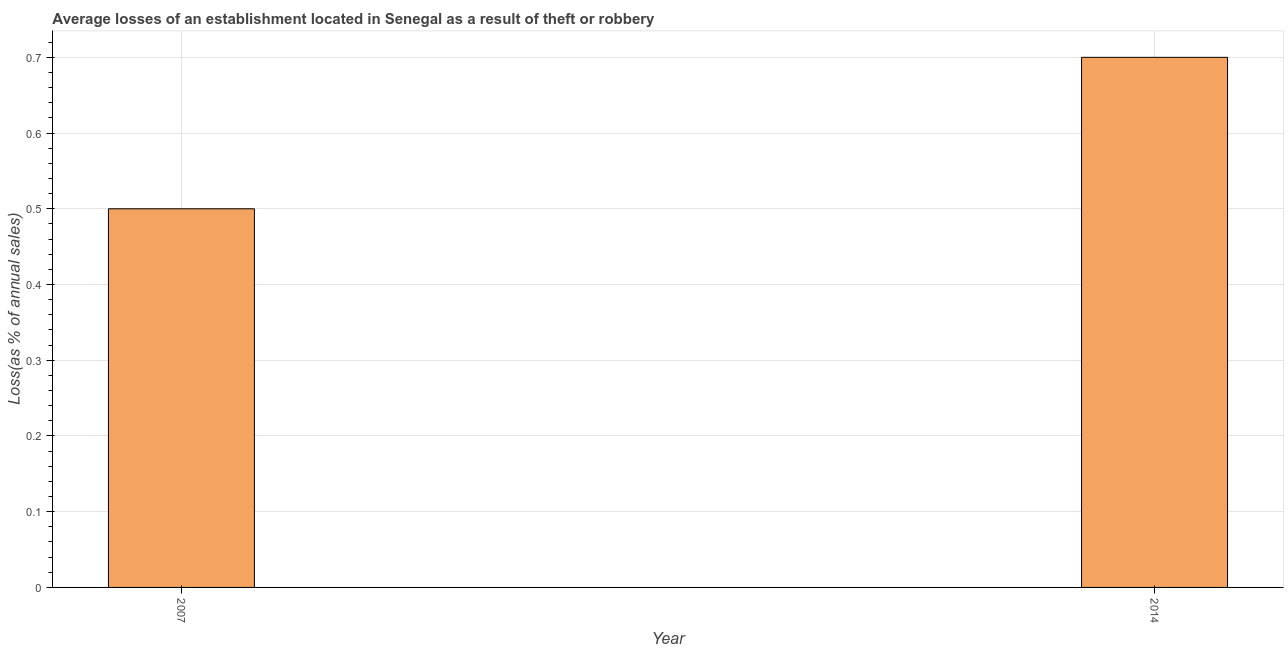Does the graph contain any zero values?
Your answer should be very brief. No. Does the graph contain grids?
Offer a terse response. Yes. What is the title of the graph?
Offer a very short reply. Average losses of an establishment located in Senegal as a result of theft or robbery. What is the label or title of the Y-axis?
Provide a short and direct response. Loss(as % of annual sales). Across all years, what is the maximum losses due to theft?
Make the answer very short. 0.7. What is the median losses due to theft?
Provide a succinct answer. 0.6. What is the ratio of the losses due to theft in 2007 to that in 2014?
Offer a terse response. 0.71. How many bars are there?
Ensure brevity in your answer.  2. Are all the bars in the graph horizontal?
Ensure brevity in your answer.  No. What is the difference between two consecutive major ticks on the Y-axis?
Your response must be concise. 0.1. Are the values on the major ticks of Y-axis written in scientific E-notation?
Ensure brevity in your answer.  No. What is the Loss(as % of annual sales) in 2007?
Offer a very short reply. 0.5. What is the Loss(as % of annual sales) in 2014?
Keep it short and to the point. 0.7. What is the ratio of the Loss(as % of annual sales) in 2007 to that in 2014?
Your response must be concise. 0.71. 